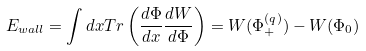Convert formula to latex. <formula><loc_0><loc_0><loc_500><loc_500>E _ { w a l l } = \int d x T r \left ( { \frac { d \Phi } { d x } } { \frac { d W } { d \Phi } } \right ) = W ( \Phi _ { + } ^ { ( q ) } ) - W ( \Phi _ { 0 } )</formula> 